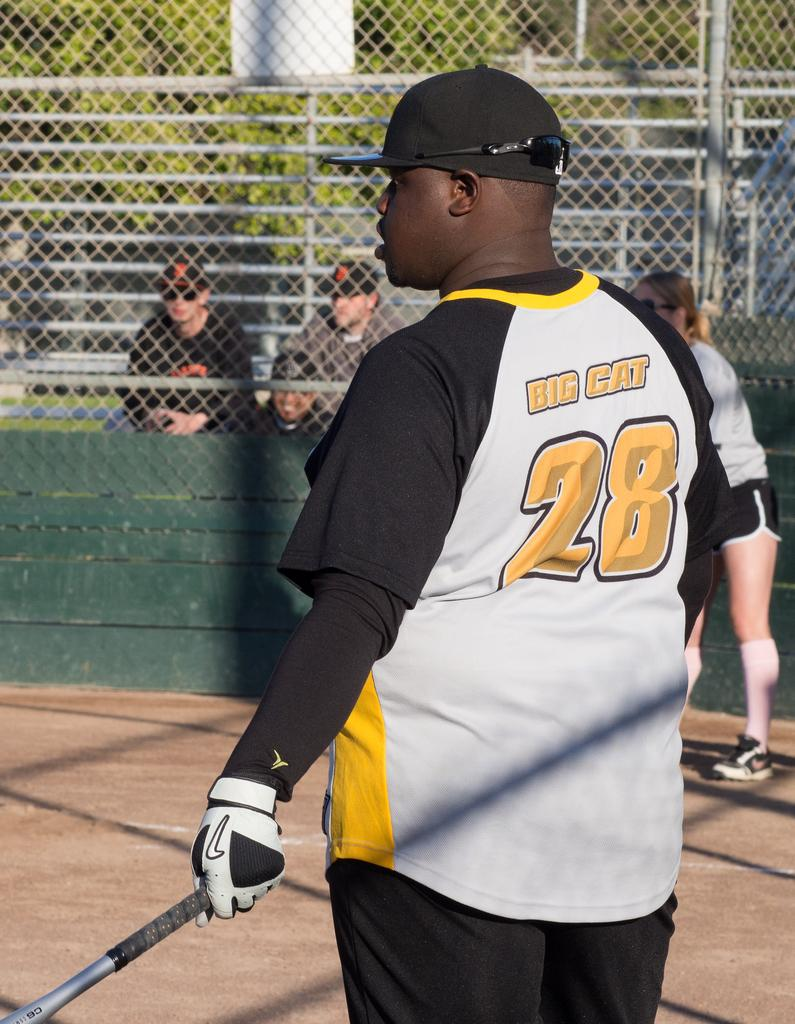<image>
Relay a brief, clear account of the picture shown. A baseball player named Big Cat wears the number 28. 